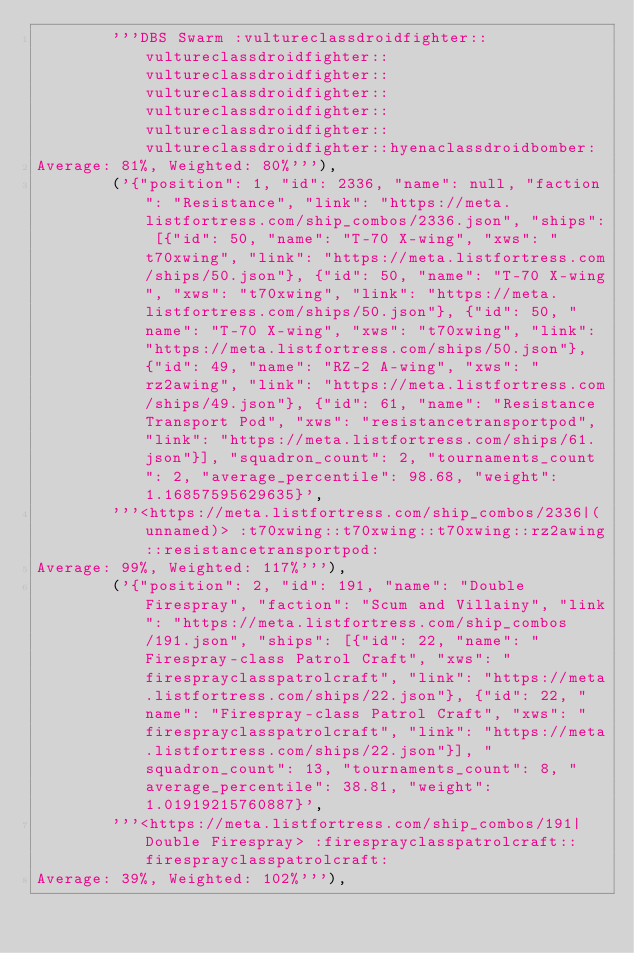<code> <loc_0><loc_0><loc_500><loc_500><_Python_>        '''DBS Swarm :vultureclassdroidfighter::vultureclassdroidfighter::vultureclassdroidfighter::vultureclassdroidfighter::vultureclassdroidfighter::vultureclassdroidfighter::vultureclassdroidfighter::hyenaclassdroidbomber:
Average: 81%, Weighted: 80%'''),
        ('{"position": 1, "id": 2336, "name": null, "faction": "Resistance", "link": "https://meta.listfortress.com/ship_combos/2336.json", "ships": [{"id": 50, "name": "T-70 X-wing", "xws": "t70xwing", "link": "https://meta.listfortress.com/ships/50.json"}, {"id": 50, "name": "T-70 X-wing", "xws": "t70xwing", "link": "https://meta.listfortress.com/ships/50.json"}, {"id": 50, "name": "T-70 X-wing", "xws": "t70xwing", "link": "https://meta.listfortress.com/ships/50.json"}, {"id": 49, "name": "RZ-2 A-wing", "xws": "rz2awing", "link": "https://meta.listfortress.com/ships/49.json"}, {"id": 61, "name": "Resistance Transport Pod", "xws": "resistancetransportpod", "link": "https://meta.listfortress.com/ships/61.json"}], "squadron_count": 2, "tournaments_count": 2, "average_percentile": 98.68, "weight": 1.16857595629635}',
        '''<https://meta.listfortress.com/ship_combos/2336|(unnamed)> :t70xwing::t70xwing::t70xwing::rz2awing::resistancetransportpod:
Average: 99%, Weighted: 117%'''),
        ('{"position": 2, "id": 191, "name": "Double Firespray", "faction": "Scum and Villainy", "link": "https://meta.listfortress.com/ship_combos/191.json", "ships": [{"id": 22, "name": "Firespray-class Patrol Craft", "xws": "firesprayclasspatrolcraft", "link": "https://meta.listfortress.com/ships/22.json"}, {"id": 22, "name": "Firespray-class Patrol Craft", "xws": "firesprayclasspatrolcraft", "link": "https://meta.listfortress.com/ships/22.json"}], "squadron_count": 13, "tournaments_count": 8, "average_percentile": 38.81, "weight": 1.01919215760887}',
        '''<https://meta.listfortress.com/ship_combos/191|Double Firespray> :firesprayclasspatrolcraft::firesprayclasspatrolcraft:
Average: 39%, Weighted: 102%'''),</code> 